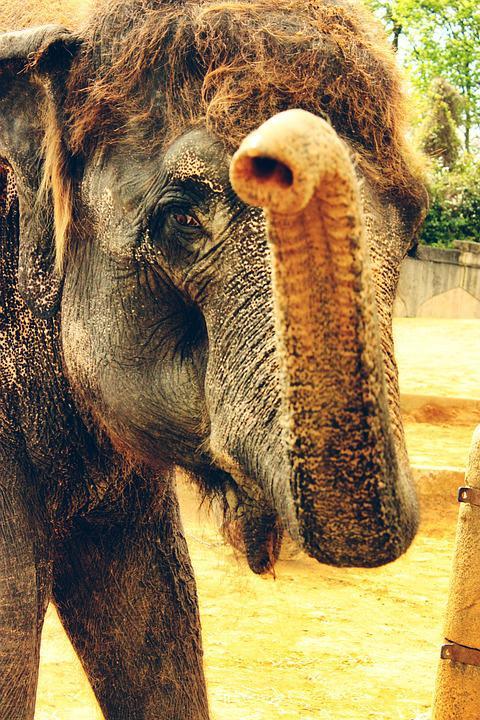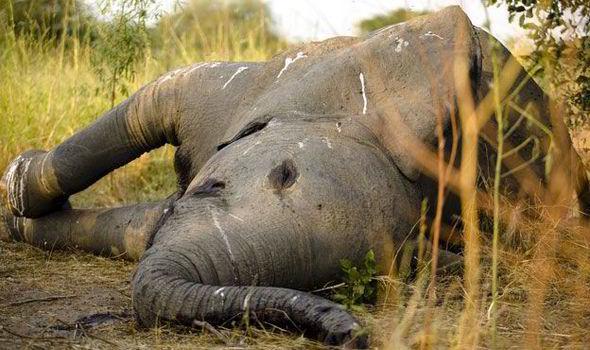The first image is the image on the left, the second image is the image on the right. Assess this claim about the two images: "There are the same number of elephants in both images.". Correct or not? Answer yes or no. Yes. The first image is the image on the left, the second image is the image on the right. Given the left and right images, does the statement "There's at least three elephants." hold true? Answer yes or no. No. 